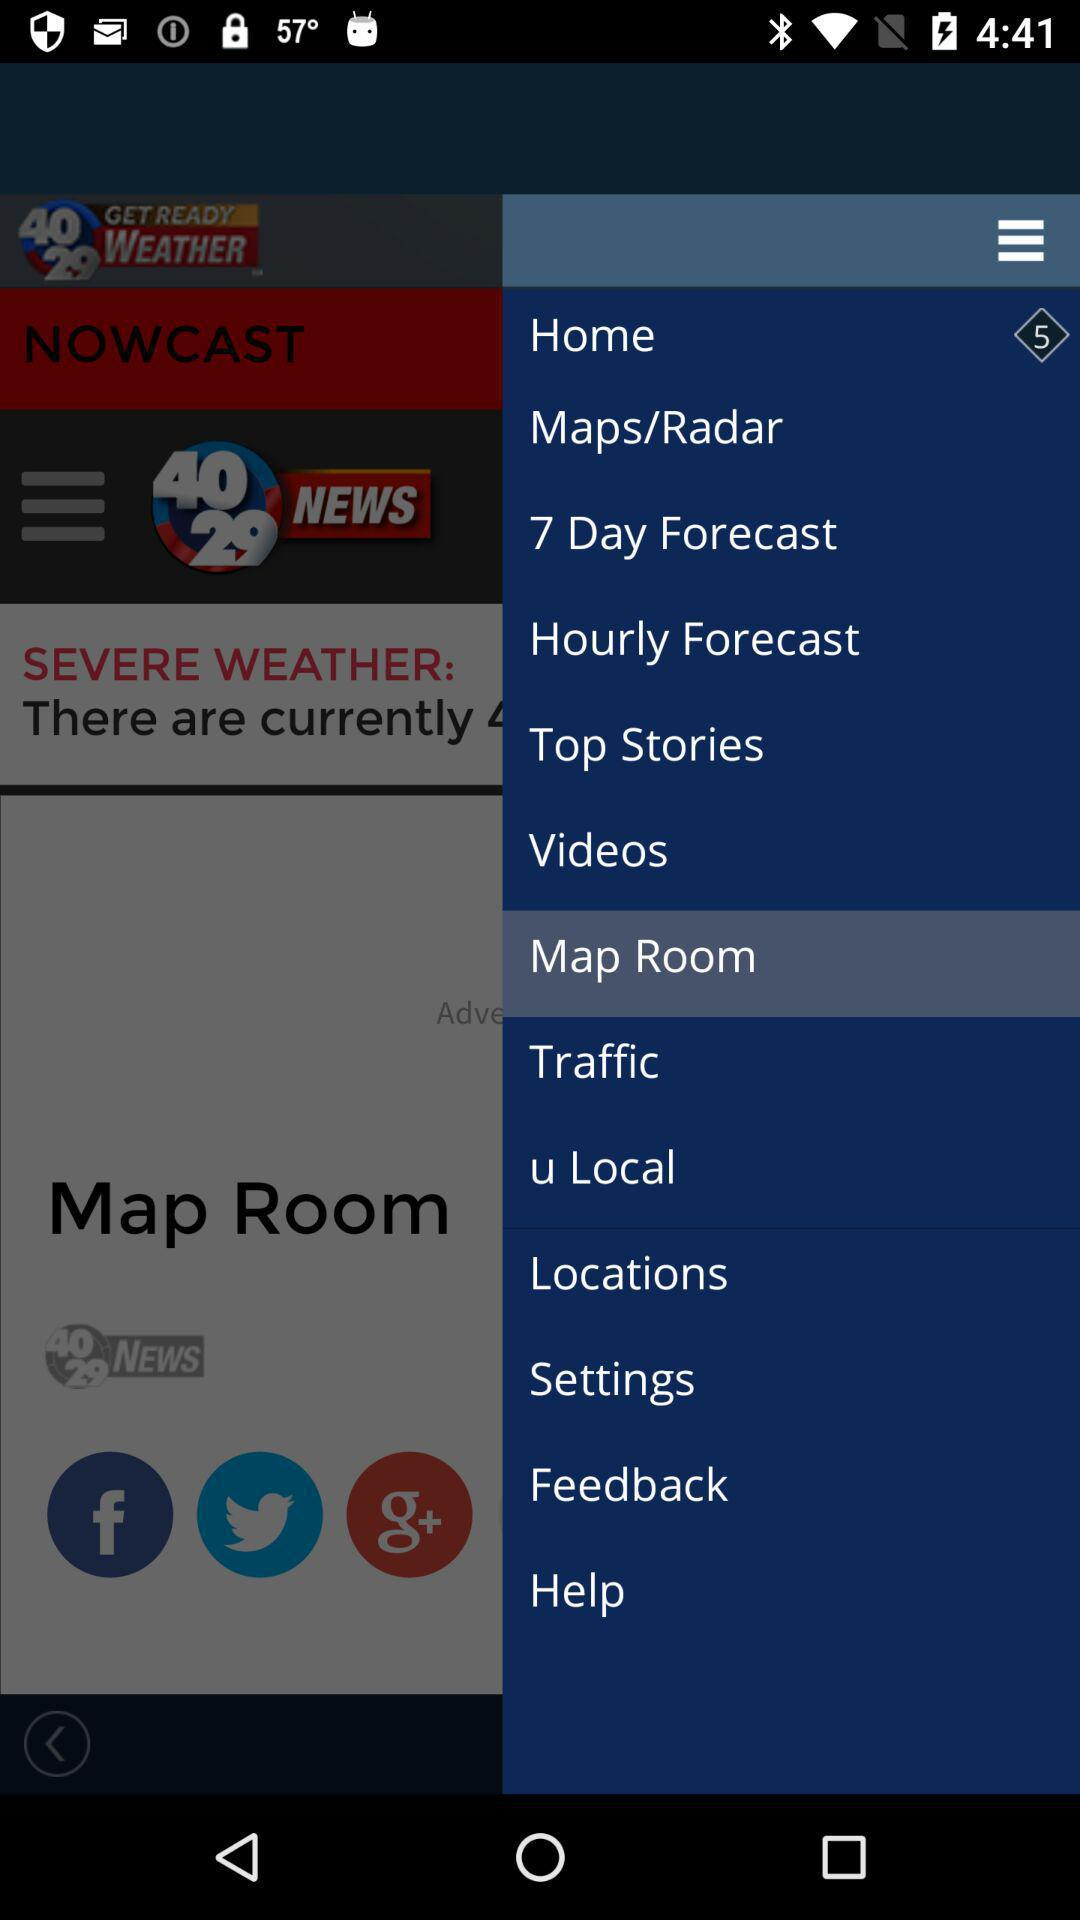What is the news channel name? The news channel names are "40 29 GET READY WEATHER" and "40 29 NEWS". 